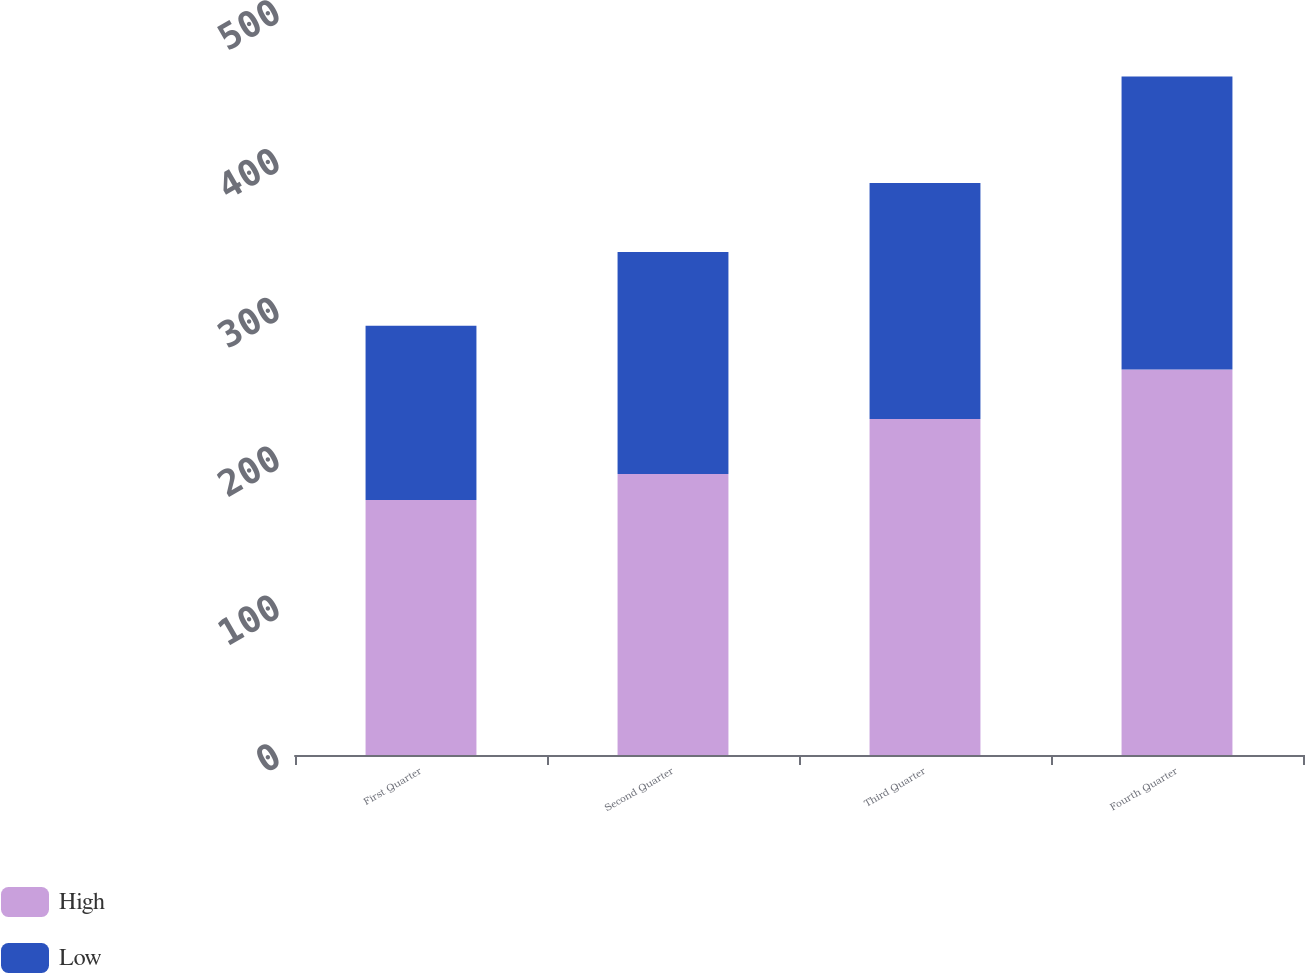<chart> <loc_0><loc_0><loc_500><loc_500><stacked_bar_chart><ecel><fcel>First Quarter<fcel>Second Quarter<fcel>Third Quarter<fcel>Fourth Quarter<nl><fcel>High<fcel>171.41<fcel>188.77<fcel>225.83<fcel>259<nl><fcel>Low<fcel>117.06<fcel>149.34<fcel>158.57<fcel>196.95<nl></chart> 